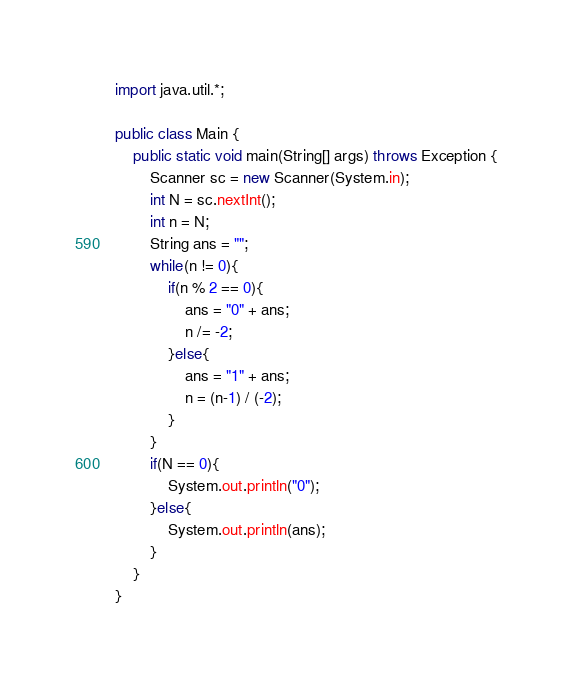<code> <loc_0><loc_0><loc_500><loc_500><_Java_>import java.util.*;

public class Main {
    public static void main(String[] args) throws Exception {
        Scanner sc = new Scanner(System.in);
        int N = sc.nextInt();
        int n = N;
        String ans = "";
        while(n != 0){
            if(n % 2 == 0){
                ans = "0" + ans;
                n /= -2;
            }else{
                ans = "1" + ans;
                n = (n-1) / (-2);
            }
        }
        if(N == 0){
            System.out.println("0");
        }else{
            System.out.println(ans);
        }
    }
}
</code> 